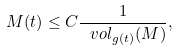Convert formula to latex. <formula><loc_0><loc_0><loc_500><loc_500>M ( t ) \leq C \frac { 1 } { \ v o l _ { g ( t ) } ( M ) } ,</formula> 